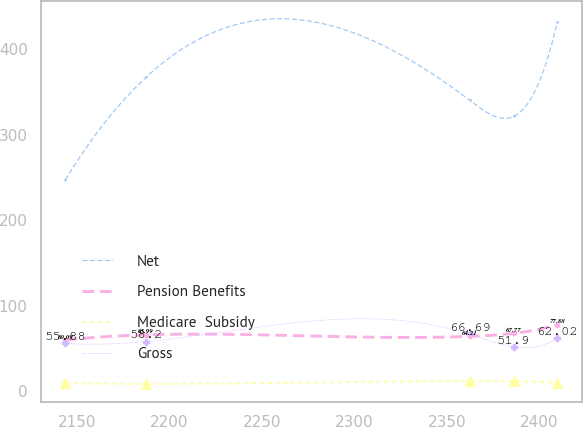Convert chart. <chart><loc_0><loc_0><loc_500><loc_500><line_chart><ecel><fcel>Net<fcel>Pension Benefits<fcel>Medicare  Subsidy<fcel>Gross<nl><fcel>2143.92<fcel>247.61<fcel>60.09<fcel>9.32<fcel>55.88<nl><fcel>2187.44<fcel>367.38<fcel>65.99<fcel>8.5<fcel>58.2<nl><fcel>2362.6<fcel>340.28<fcel>64.21<fcel>11.93<fcel>66.69<nl><fcel>2386.18<fcel>321.63<fcel>67.77<fcel>11.61<fcel>51.9<nl><fcel>2409.76<fcel>432.05<fcel>77.88<fcel>9.88<fcel>62.02<nl></chart> 